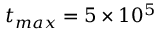<formula> <loc_0><loc_0><loc_500><loc_500>t _ { \max } = 5 \times 1 0 ^ { 5 }</formula> 